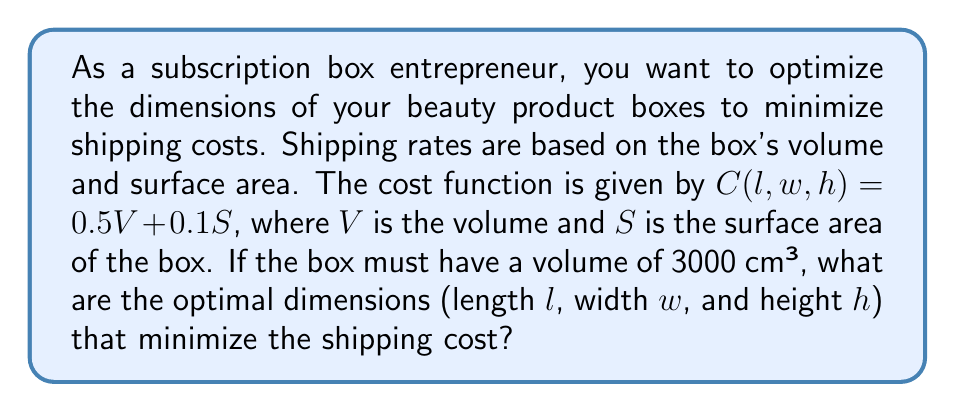Could you help me with this problem? To solve this problem, we'll use the method of Lagrange multipliers on a manifold.

1) First, let's define our constraints:
   - Volume constraint: $V = lwh = 3000$ cm³
   - Surface area: $S = 2(lw + lh + wh)$

2) The cost function is:
   $C(l,w,h) = 0.5V + 0.1S = 0.5(3000) + 0.2(lw + lh + wh)$

3) We want to minimize $C$ subject to the constraint $g(l,w,h) = lwh - 3000 = 0$

4) Form the Lagrangian:
   $L(l,w,h,\lambda) = 1500 + 0.2(lw + lh + wh) + \lambda(lwh - 3000)$

5) Take partial derivatives and set them to zero:
   $$\frac{\partial L}{\partial l} = 0.2(w + h) + \lambda wh = 0$$
   $$\frac{\partial L}{\partial w} = 0.2(l + h) + \lambda lh = 0$$
   $$\frac{\partial L}{\partial h} = 0.2(l + w) + \lambda lw = 0$$
   $$\frac{\partial L}{\partial \lambda} = lwh - 3000 = 0$$

6) From these equations, we can deduce that $l = w = h$ (due to symmetry)

7) Substituting this into the volume constraint:
   $l^3 = 3000$
   $l = w = h = \sqrt[3]{3000} \approx 14.42$ cm

8) To verify this is a minimum, we could check the second derivatives, but the symmetry of the problem and the nature of the cost function assure us this is indeed a minimum.
Answer: The optimal dimensions for the subscription box are:
Length $l \approx 14.42$ cm
Width $w \approx 14.42$ cm
Height $h \approx 14.42$ cm 